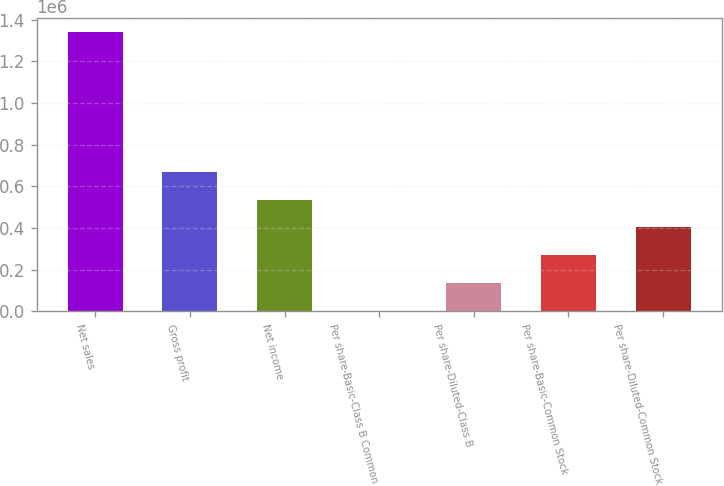Convert chart. <chart><loc_0><loc_0><loc_500><loc_500><bar_chart><fcel>Net sales<fcel>Gross profit<fcel>Net income<fcel>Per share-Basic-Class B Common<fcel>Per share-Diluted-Class B<fcel>Per share-Basic-Common Stock<fcel>Per share-Diluted-Common Stock<nl><fcel>1.34222e+06<fcel>671111<fcel>536889<fcel>0.22<fcel>134222<fcel>268445<fcel>402667<nl></chart> 